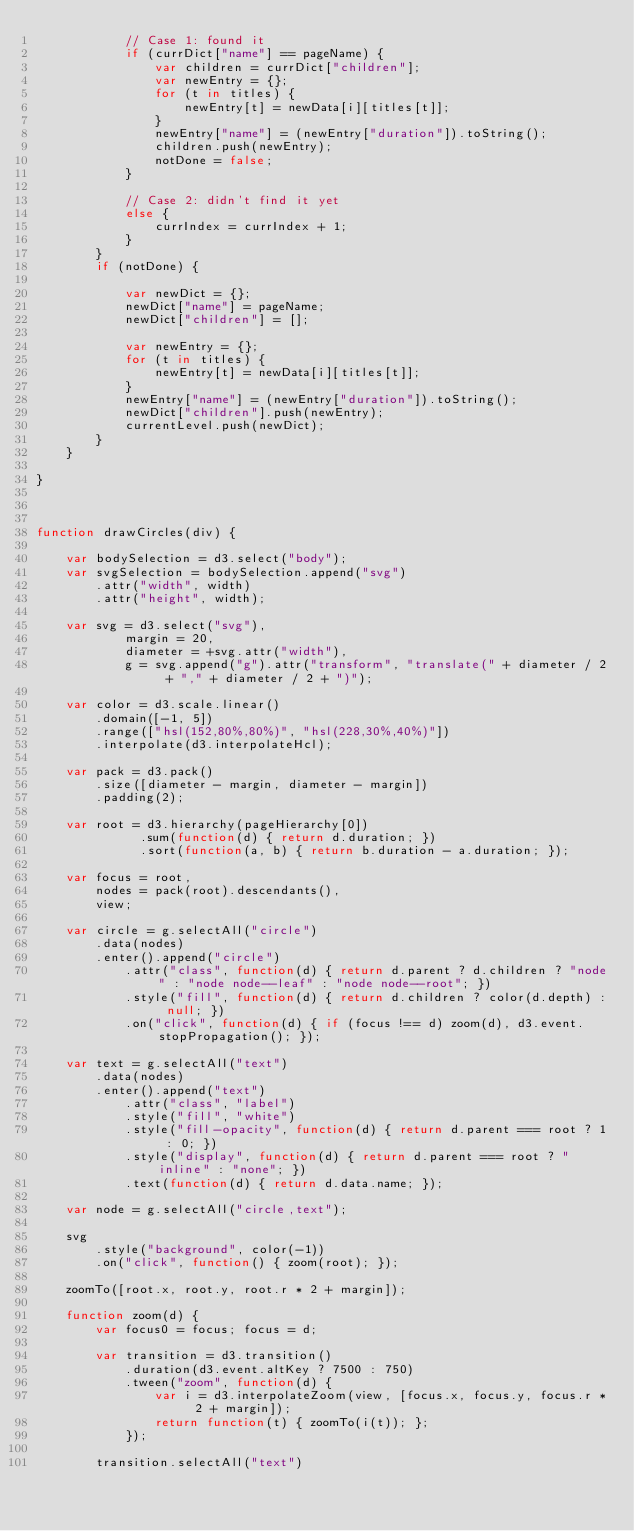Convert code to text. <code><loc_0><loc_0><loc_500><loc_500><_JavaScript_>            // Case 1: found it
            if (currDict["name"] == pageName) { 
                var children = currDict["children"]; 
                var newEntry = {};
                for (t in titles) {
                    newEntry[t] = newData[i][titles[t]];
                }
                newEntry["name"] = (newEntry["duration"]).toString();
                children.push(newEntry);
                notDone = false;
            } 

            // Case 2: didn't find it yet
            else { 
                currIndex = currIndex + 1;
            }
        }
        if (notDone) {

            var newDict = {};
            newDict["name"] = pageName;
            newDict["children"] = [];

            var newEntry = {};
            for (t in titles) {
                newEntry[t] = newData[i][titles[t]];
            }
            newEntry["name"] = (newEntry["duration"]).toString();
            newDict["children"].push(newEntry);
            currentLevel.push(newDict);
        }
    }   

}



function drawCircles(div) {

    var bodySelection = d3.select("body");
    var svgSelection = bodySelection.append("svg")
        .attr("width", width)
        .attr("height", width);

    var svg = d3.select("svg"),
            margin = 20,
            diameter = +svg.attr("width"),
            g = svg.append("g").attr("transform", "translate(" + diameter / 2 + "," + diameter / 2 + ")");

    var color = d3.scale.linear()
        .domain([-1, 5])
        .range(["hsl(152,80%,80%)", "hsl(228,30%,40%)"])
        .interpolate(d3.interpolateHcl);

    var pack = d3.pack()
        .size([diameter - margin, diameter - margin])
        .padding(2);

    var root = d3.hierarchy(pageHierarchy[0])
              .sum(function(d) { return d.duration; })
              .sort(function(a, b) { return b.duration - a.duration; });

    var focus = root,
        nodes = pack(root).descendants(),
        view;

    var circle = g.selectAll("circle")
        .data(nodes)
        .enter().append("circle")
            .attr("class", function(d) { return d.parent ? d.children ? "node" : "node node--leaf" : "node node--root"; })
            .style("fill", function(d) { return d.children ? color(d.depth) : null; })
            .on("click", function(d) { if (focus !== d) zoom(d), d3.event.stopPropagation(); });

    var text = g.selectAll("text")
        .data(nodes)
        .enter().append("text")
            .attr("class", "label")
            .style("fill", "white")
            .style("fill-opacity", function(d) { return d.parent === root ? 1 : 0; })
            .style("display", function(d) { return d.parent === root ? "inline" : "none"; })
            .text(function(d) { return d.data.name; });

    var node = g.selectAll("circle,text");

    svg
        .style("background", color(-1))
        .on("click", function() { zoom(root); });

    zoomTo([root.x, root.y, root.r * 2 + margin]);

    function zoom(d) {
        var focus0 = focus; focus = d;

        var transition = d3.transition()
            .duration(d3.event.altKey ? 7500 : 750)
            .tween("zoom", function(d) {
                var i = d3.interpolateZoom(view, [focus.x, focus.y, focus.r * 2 + margin]);
                return function(t) { zoomTo(i(t)); };
            });

        transition.selectAll("text")</code> 